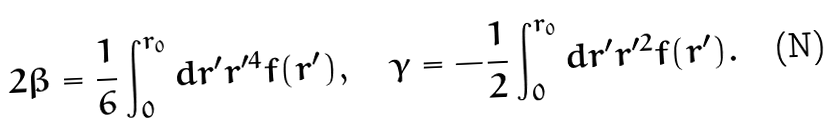Convert formula to latex. <formula><loc_0><loc_0><loc_500><loc_500>2 \beta = \frac { 1 } { 6 } \int _ { 0 } ^ { r _ { 0 } } d r ^ { \prime } r ^ { \prime 4 } f ( r ^ { \prime } ) , \quad \gamma = - \frac { 1 } { 2 } \int _ { 0 } ^ { r _ { 0 } } d r ^ { \prime } r ^ { \prime 2 } f ( r ^ { \prime } ) .</formula> 